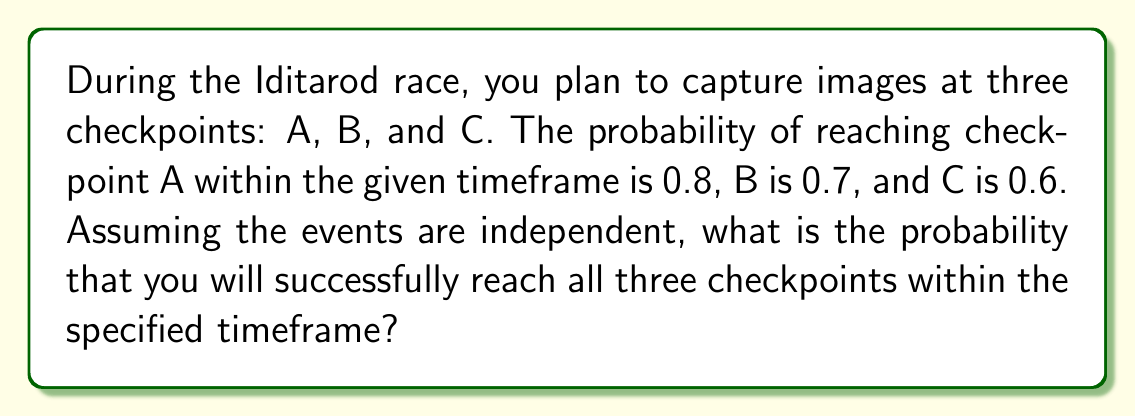What is the answer to this math problem? To solve this problem, we need to follow these steps:

1. Identify the given probabilities:
   P(A) = 0.8 (probability of reaching checkpoint A)
   P(B) = 0.7 (probability of reaching checkpoint B)
   P(C) = 0.6 (probability of reaching checkpoint C)

2. Recognize that we need to calculate the probability of all events occurring simultaneously.

3. Since the events are independent, we can use the multiplication rule of probability:
   P(A and B and C) = P(A) × P(B) × P(C)

4. Substitute the given probabilities into the formula:
   P(A and B and C) = 0.8 × 0.7 × 0.6

5. Calculate the result:
   P(A and B and C) = 0.336

Therefore, the probability of successfully reaching all three checkpoints within the specified timeframe is 0.336 or 33.6%.
Answer: 0.336 